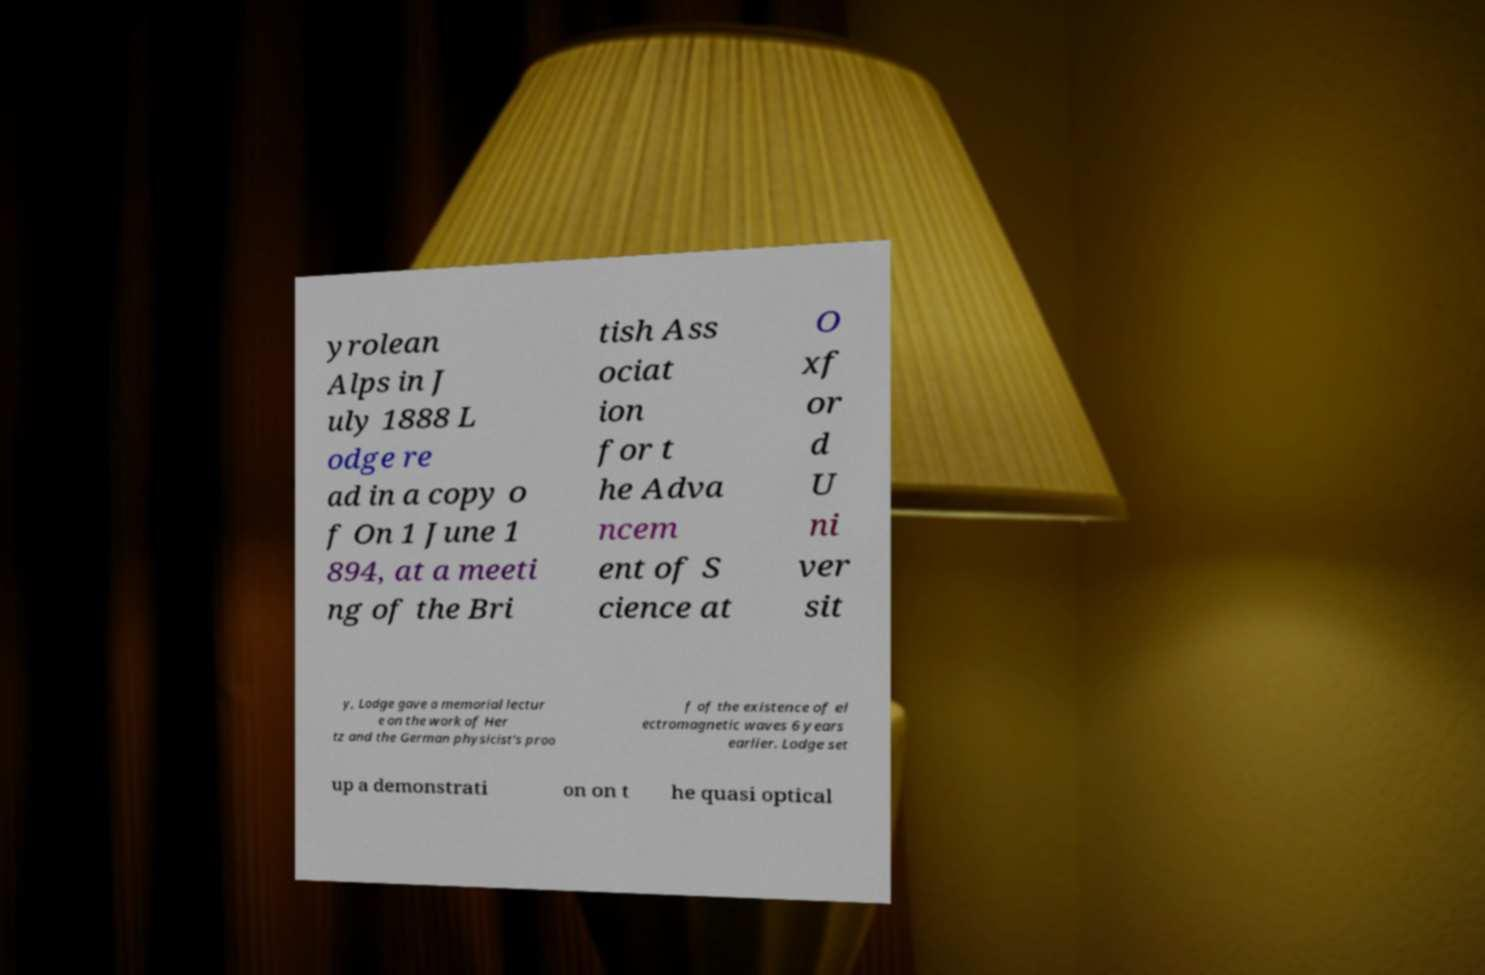I need the written content from this picture converted into text. Can you do that? yrolean Alps in J uly 1888 L odge re ad in a copy o f On 1 June 1 894, at a meeti ng of the Bri tish Ass ociat ion for t he Adva ncem ent of S cience at O xf or d U ni ver sit y, Lodge gave a memorial lectur e on the work of Her tz and the German physicist's proo f of the existence of el ectromagnetic waves 6 years earlier. Lodge set up a demonstrati on on t he quasi optical 